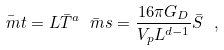<formula> <loc_0><loc_0><loc_500><loc_500>\bar { \ m t } = L \bar { T } ^ { a } \bar { \ m s } = \frac { 1 6 \pi G _ { D } } { V _ { p } L ^ { d - 1 } } \bar { S } \ ,</formula> 